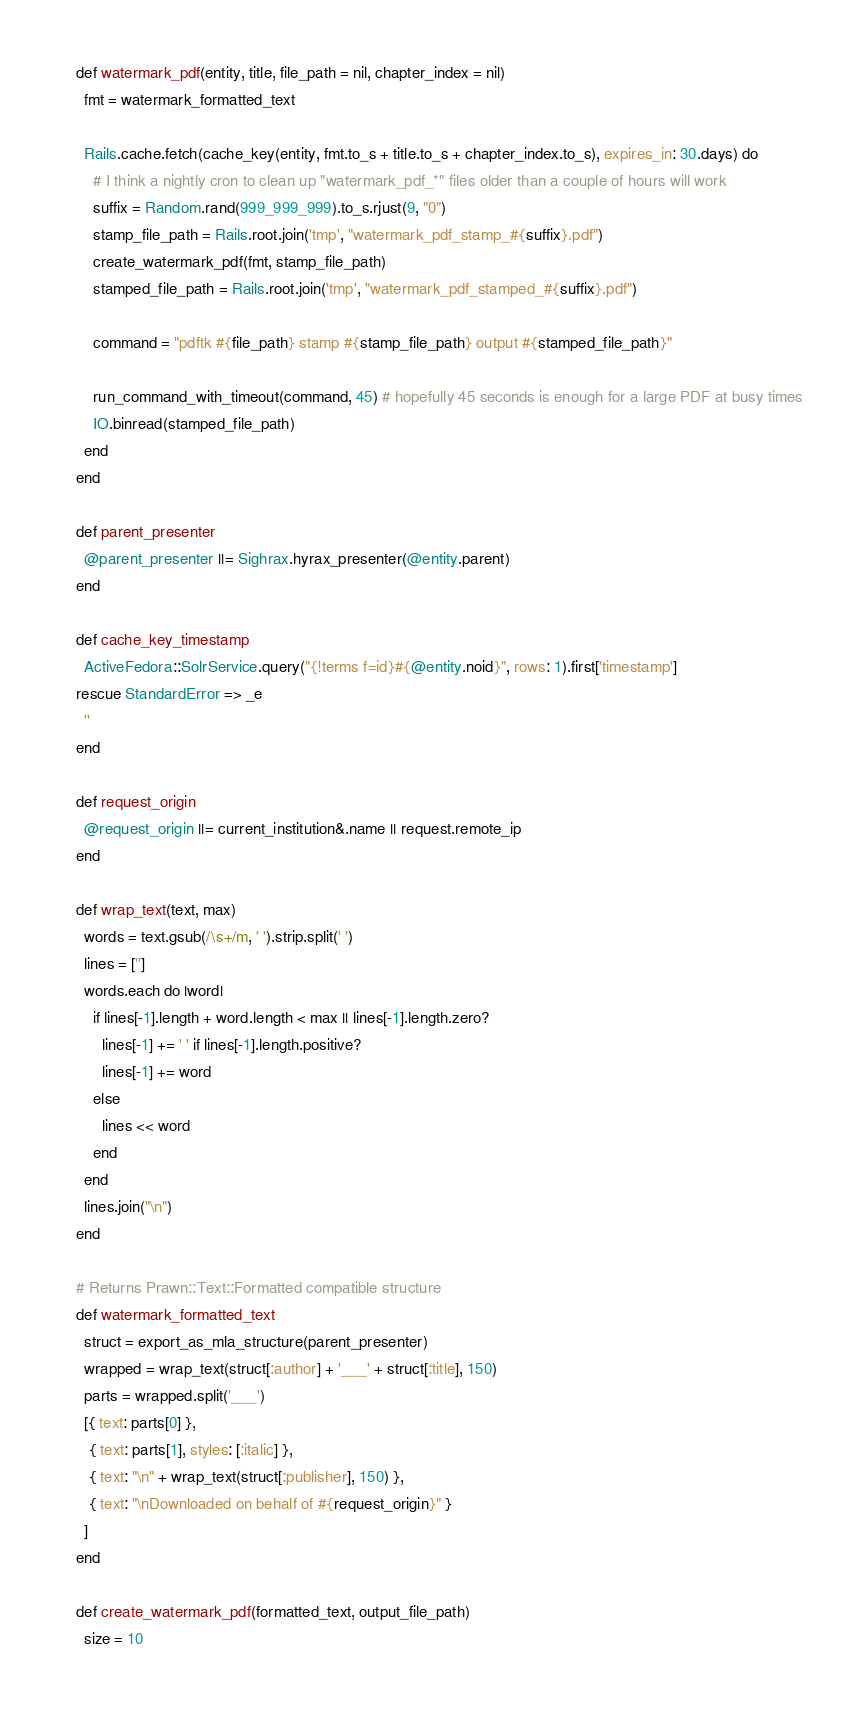Convert code to text. <code><loc_0><loc_0><loc_500><loc_500><_Ruby_>
    def watermark_pdf(entity, title, file_path = nil, chapter_index = nil)
      fmt = watermark_formatted_text

      Rails.cache.fetch(cache_key(entity, fmt.to_s + title.to_s + chapter_index.to_s), expires_in: 30.days) do
        # I think a nightly cron to clean up "watermark_pdf_*" files older than a couple of hours will work
        suffix = Random.rand(999_999_999).to_s.rjust(9, "0")
        stamp_file_path = Rails.root.join('tmp', "watermark_pdf_stamp_#{suffix}.pdf")
        create_watermark_pdf(fmt, stamp_file_path)
        stamped_file_path = Rails.root.join('tmp', "watermark_pdf_stamped_#{suffix}.pdf")

        command = "pdftk #{file_path} stamp #{stamp_file_path} output #{stamped_file_path}"

        run_command_with_timeout(command, 45) # hopefully 45 seconds is enough for a large PDF at busy times
        IO.binread(stamped_file_path)
      end
    end

    def parent_presenter
      @parent_presenter ||= Sighrax.hyrax_presenter(@entity.parent)
    end

    def cache_key_timestamp
      ActiveFedora::SolrService.query("{!terms f=id}#{@entity.noid}", rows: 1).first['timestamp']
    rescue StandardError => _e
      ''
    end

    def request_origin
      @request_origin ||= current_institution&.name || request.remote_ip
    end

    def wrap_text(text, max)
      words = text.gsub(/\s+/m, ' ').strip.split(' ')
      lines = ['']
      words.each do |word|
        if lines[-1].length + word.length < max || lines[-1].length.zero?
          lines[-1] += ' ' if lines[-1].length.positive?
          lines[-1] += word
        else
          lines << word
        end
      end
      lines.join("\n")
    end

    # Returns Prawn::Text::Formatted compatible structure
    def watermark_formatted_text
      struct = export_as_mla_structure(parent_presenter)
      wrapped = wrap_text(struct[:author] + '___' + struct[:title], 150)
      parts = wrapped.split('___')
      [{ text: parts[0] },
       { text: parts[1], styles: [:italic] },
       { text: "\n" + wrap_text(struct[:publisher], 150) },
       { text: "\nDownloaded on behalf of #{request_origin}" }
      ]
    end

    def create_watermark_pdf(formatted_text, output_file_path)
      size = 10</code> 